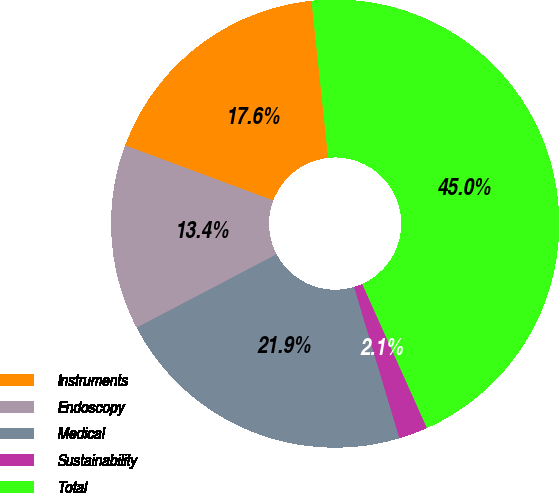Convert chart to OTSL. <chart><loc_0><loc_0><loc_500><loc_500><pie_chart><fcel>Instruments<fcel>Endoscopy<fcel>Medical<fcel>Sustainability<fcel>Total<nl><fcel>17.65%<fcel>13.36%<fcel>21.94%<fcel>2.09%<fcel>44.96%<nl></chart> 